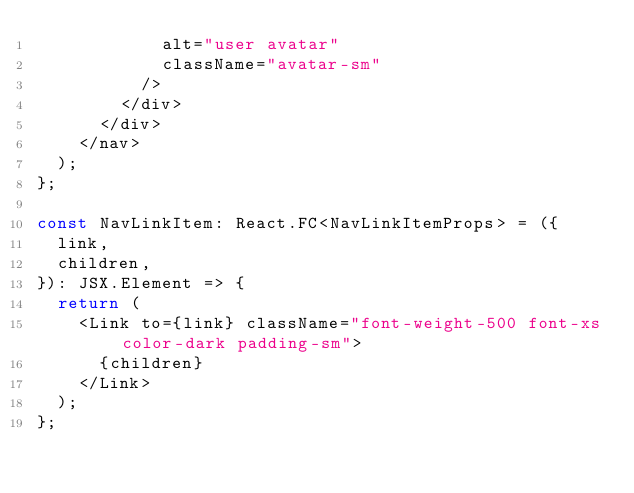Convert code to text. <code><loc_0><loc_0><loc_500><loc_500><_TypeScript_>            alt="user avatar"
            className="avatar-sm"
          />
        </div>
      </div>
    </nav>
  );
};

const NavLinkItem: React.FC<NavLinkItemProps> = ({
  link,
  children,
}): JSX.Element => {
  return (
    <Link to={link} className="font-weight-500 font-xs color-dark padding-sm">
      {children}
    </Link>
  );
};
</code> 